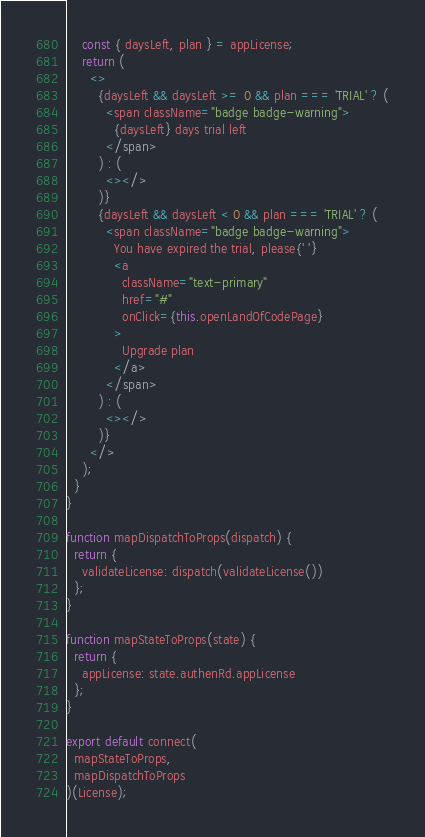<code> <loc_0><loc_0><loc_500><loc_500><_JavaScript_>    const { daysLeft, plan } = appLicense;
    return (
      <>
        {daysLeft && daysLeft >= 0 && plan === 'TRIAL' ? (
          <span className="badge badge-warning">
            {daysLeft} days trial left
          </span>
        ) : (
          <></>
        )}
        {daysLeft && daysLeft < 0 && plan === 'TRIAL' ? (
          <span className="badge badge-warning">
            You have expired the trial, please{' '}
            <a
              className="text-primary"
              href="#"
              onClick={this.openLandOfCodePage}
            >
              Upgrade plan
            </a>
          </span>
        ) : (
          <></>
        )}
      </>
    );
  }
}

function mapDispatchToProps(dispatch) {
  return {
    validateLicense: dispatch(validateLicense())
  };
}

function mapStateToProps(state) {
  return {
    appLicense: state.authenRd.appLicense
  };
}

export default connect(
  mapStateToProps,
  mapDispatchToProps
)(License);
</code> 